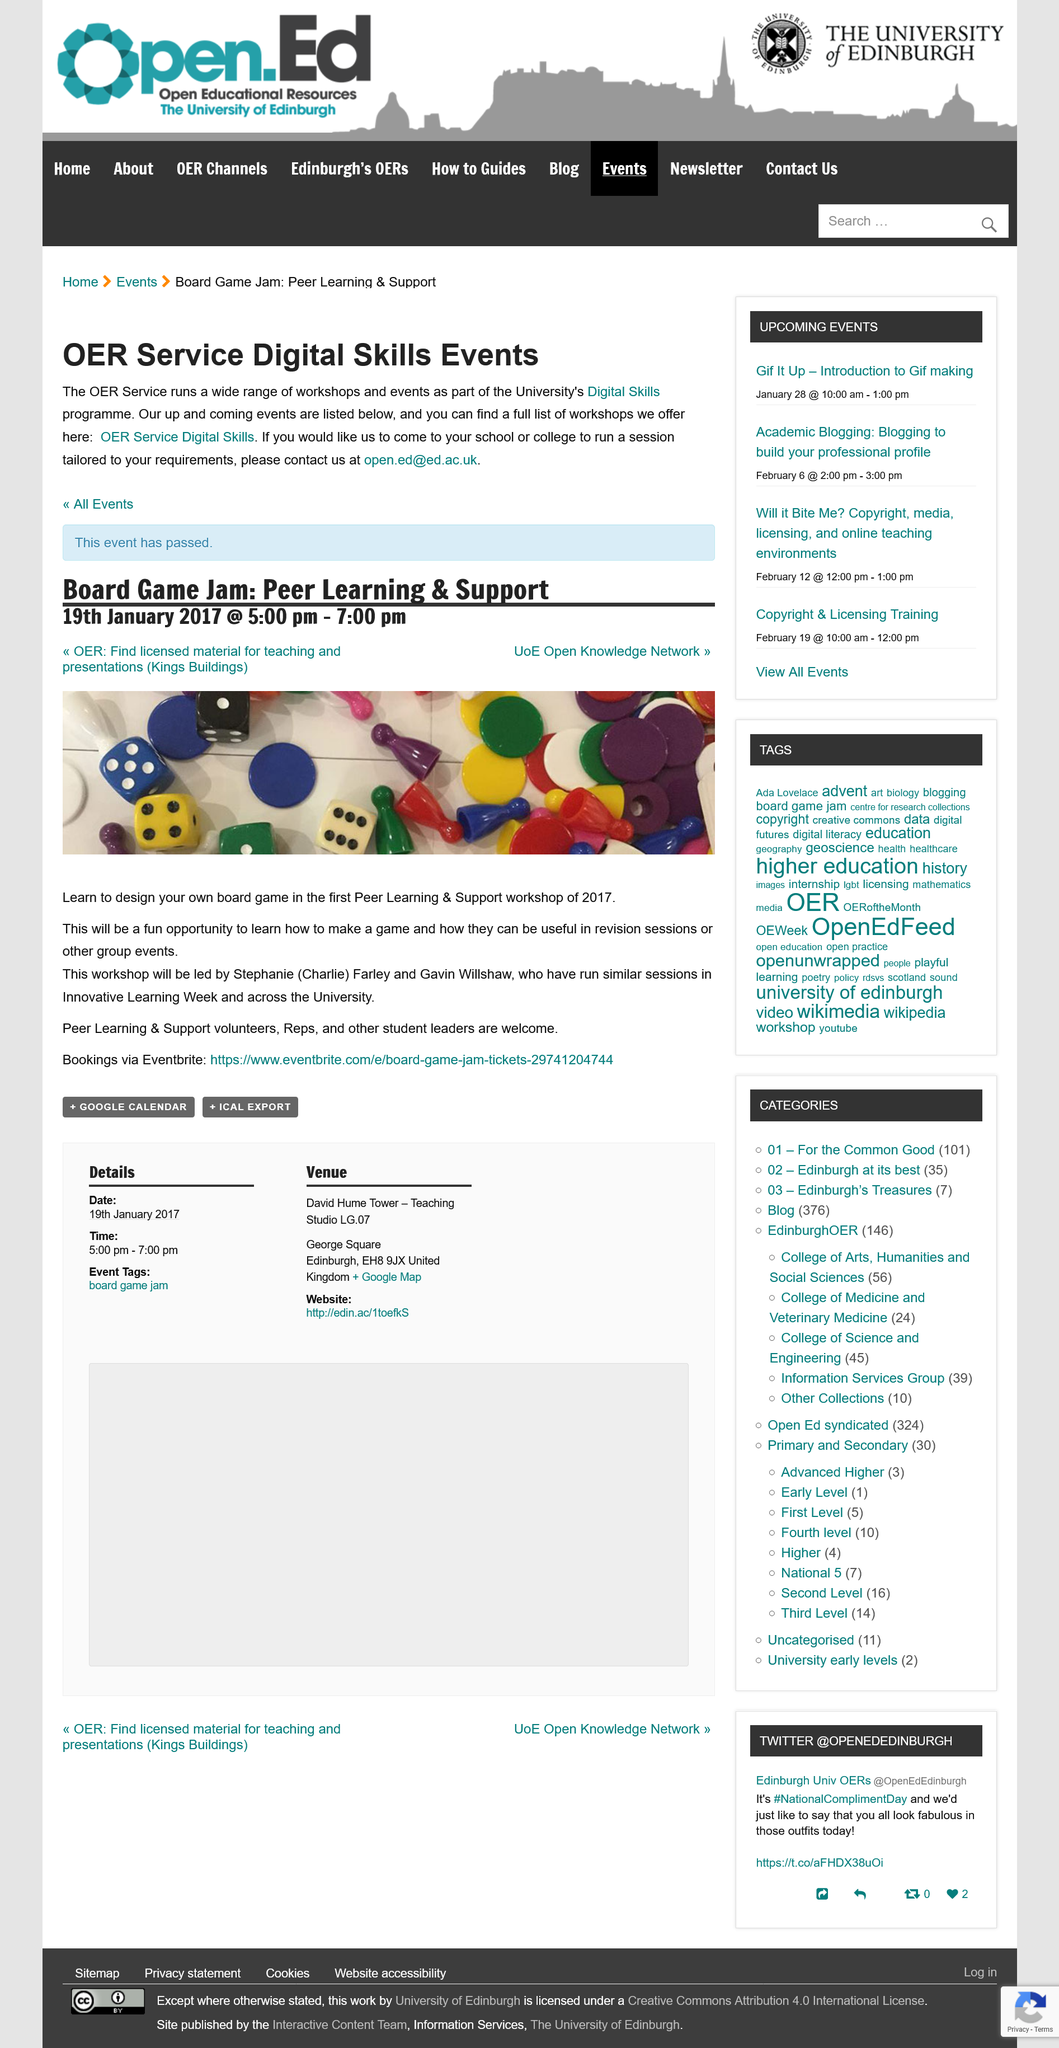Outline some significant characteristics in this image. The photograph advertises a workshop that enables individuals to develop their skills in designing their own board games. The workshop will take place on January 19, 2017, between the hours of 5 and 7 pm. It has been decided that Stephanie (Charlie) Farley and Gavin Willshaw will lead the upcoming workshop. 